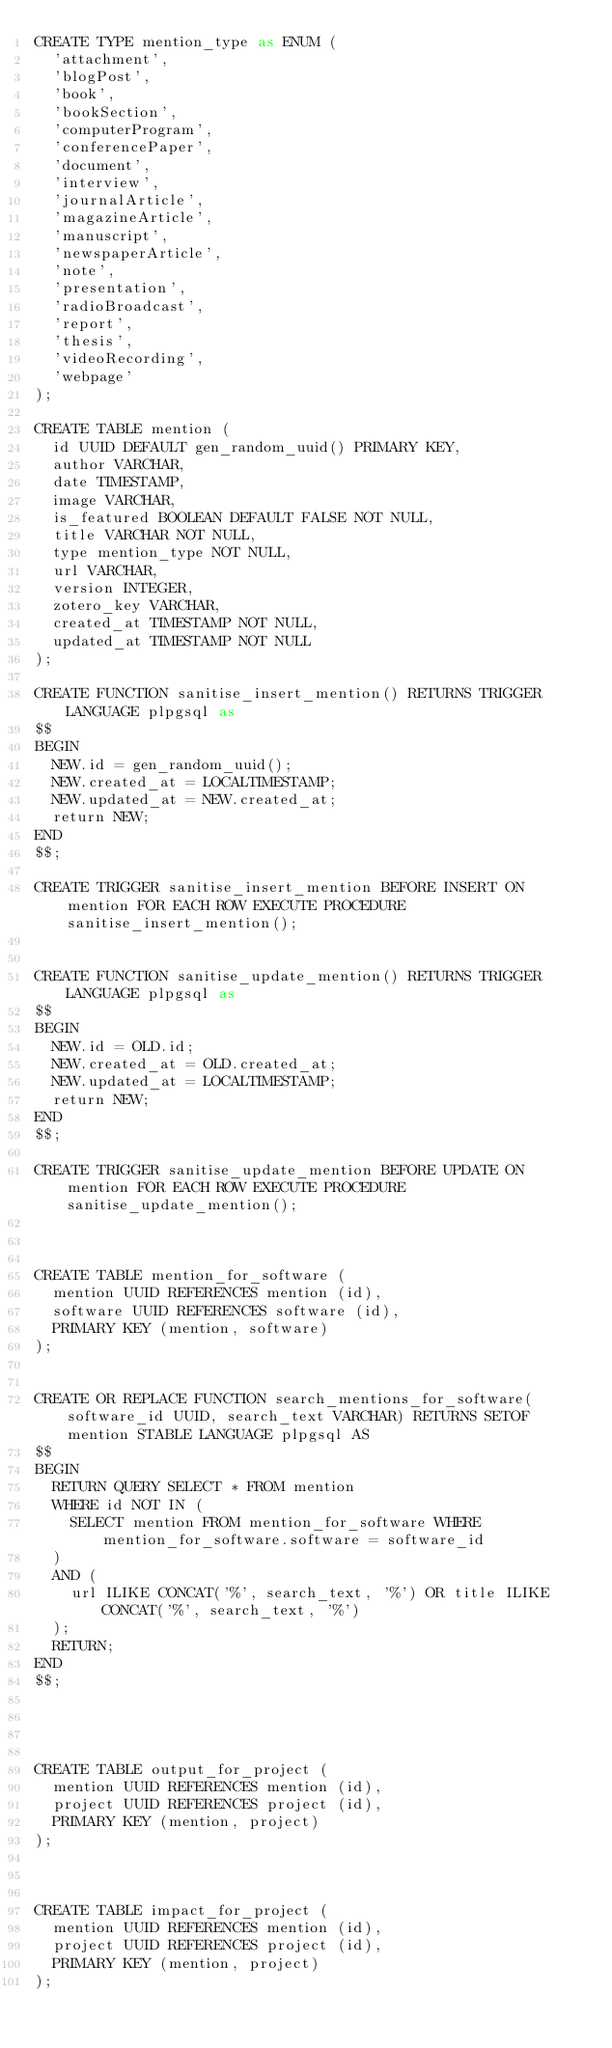<code> <loc_0><loc_0><loc_500><loc_500><_SQL_>CREATE TYPE mention_type as ENUM (
	'attachment',
	'blogPost',
	'book',
	'bookSection',
	'computerProgram',
	'conferencePaper',
	'document',
	'interview',
	'journalArticle',
	'magazineArticle',
	'manuscript',
	'newspaperArticle',
	'note',
	'presentation',
	'radioBroadcast',
	'report',
	'thesis',
	'videoRecording',
	'webpage'
);

CREATE TABLE mention (
	id UUID DEFAULT gen_random_uuid() PRIMARY KEY,
	author VARCHAR,
	date TIMESTAMP,
	image VARCHAR,
	is_featured BOOLEAN DEFAULT FALSE NOT NULL,
	title VARCHAR NOT NULL,
	type mention_type NOT NULL,
	url VARCHAR,
	version INTEGER,
	zotero_key VARCHAR,
	created_at TIMESTAMP NOT NULL,
	updated_at TIMESTAMP NOT NULL
);

CREATE FUNCTION sanitise_insert_mention() RETURNS TRIGGER LANGUAGE plpgsql as
$$
BEGIN
	NEW.id = gen_random_uuid();
	NEW.created_at = LOCALTIMESTAMP;
	NEW.updated_at = NEW.created_at;
	return NEW;
END
$$;

CREATE TRIGGER sanitise_insert_mention BEFORE INSERT ON mention FOR EACH ROW EXECUTE PROCEDURE sanitise_insert_mention();


CREATE FUNCTION sanitise_update_mention() RETURNS TRIGGER LANGUAGE plpgsql as
$$
BEGIN
	NEW.id = OLD.id;
	NEW.created_at = OLD.created_at;
	NEW.updated_at = LOCALTIMESTAMP;
	return NEW;
END
$$;

CREATE TRIGGER sanitise_update_mention BEFORE UPDATE ON mention FOR EACH ROW EXECUTE PROCEDURE sanitise_update_mention();



CREATE TABLE mention_for_software (
	mention UUID REFERENCES mention (id),
	software UUID REFERENCES software (id),
	PRIMARY KEY (mention, software)
);


CREATE OR REPLACE FUNCTION search_mentions_for_software(software_id UUID, search_text VARCHAR) RETURNS SETOF mention STABLE LANGUAGE plpgsql AS
$$
BEGIN
	RETURN QUERY SELECT * FROM mention
	WHERE id NOT IN (
		SELECT mention FROM mention_for_software WHERE mention_for_software.software = software_id
	)
	AND (
		url ILIKE CONCAT('%', search_text, '%') OR title ILIKE CONCAT('%', search_text, '%')
	);
	RETURN;
END
$$;




CREATE TABLE output_for_project (
	mention UUID REFERENCES mention (id),
	project UUID REFERENCES project (id),
	PRIMARY KEY (mention, project)
);



CREATE TABLE impact_for_project (
	mention UUID REFERENCES mention (id),
	project UUID REFERENCES project (id),
	PRIMARY KEY (mention, project)
);
</code> 